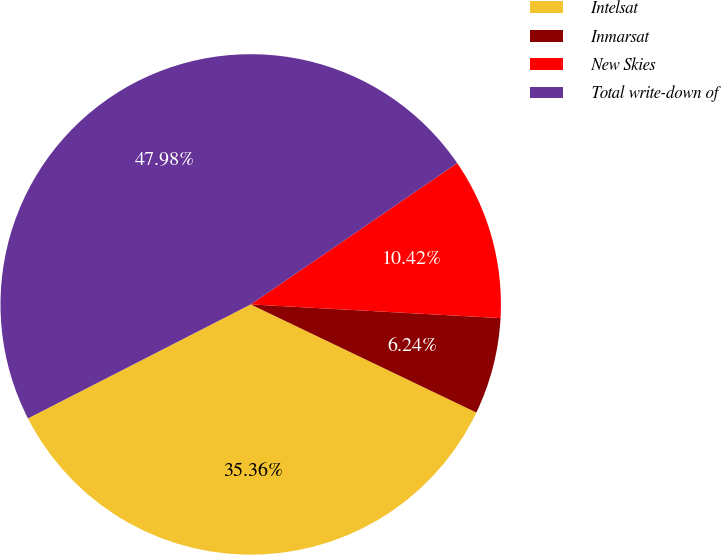Convert chart to OTSL. <chart><loc_0><loc_0><loc_500><loc_500><pie_chart><fcel>Intelsat<fcel>Inmarsat<fcel>New Skies<fcel>Total write-down of<nl><fcel>35.36%<fcel>6.24%<fcel>10.42%<fcel>47.98%<nl></chart> 